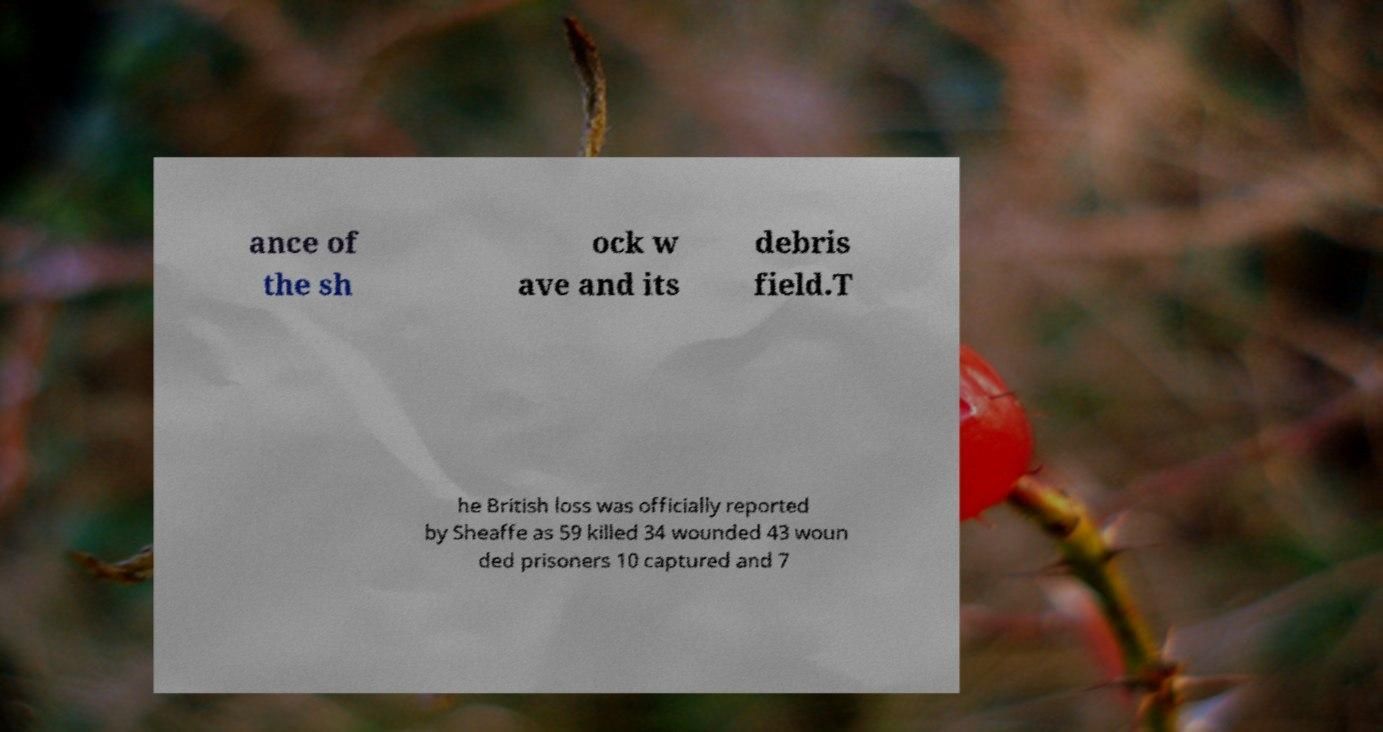For documentation purposes, I need the text within this image transcribed. Could you provide that? ance of the sh ock w ave and its debris field.T he British loss was officially reported by Sheaffe as 59 killed 34 wounded 43 woun ded prisoners 10 captured and 7 